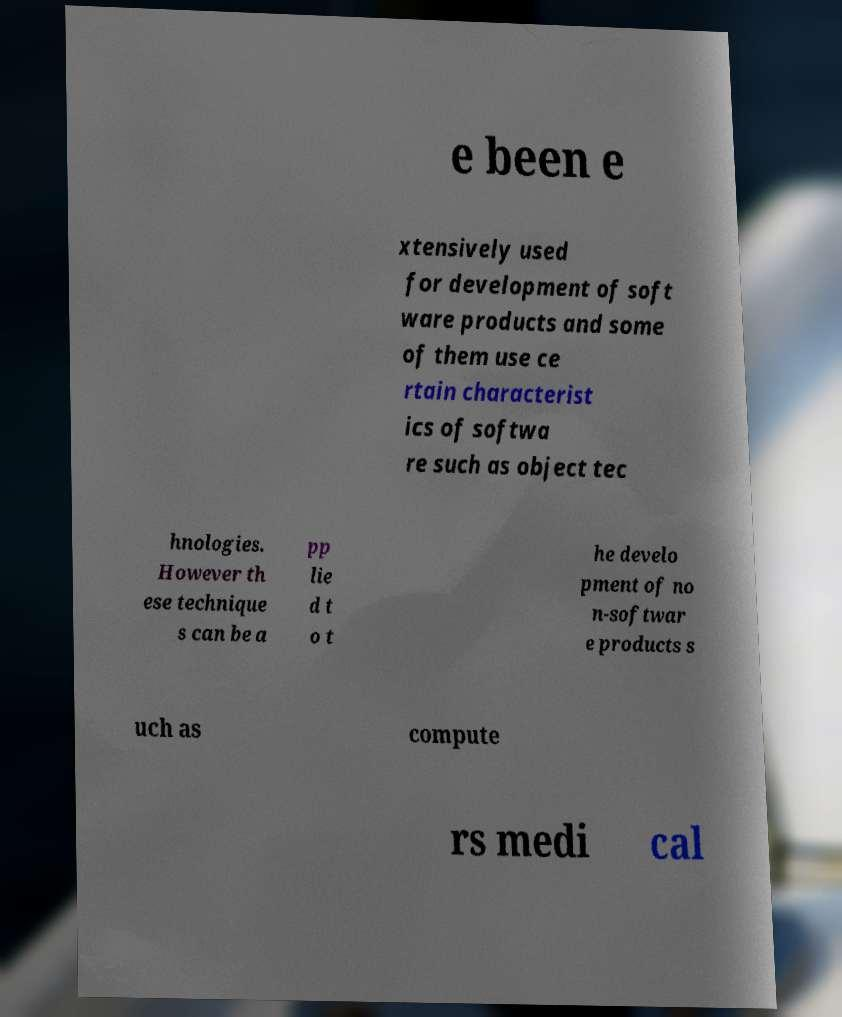Could you assist in decoding the text presented in this image and type it out clearly? e been e xtensively used for development of soft ware products and some of them use ce rtain characterist ics of softwa re such as object tec hnologies. However th ese technique s can be a pp lie d t o t he develo pment of no n-softwar e products s uch as compute rs medi cal 